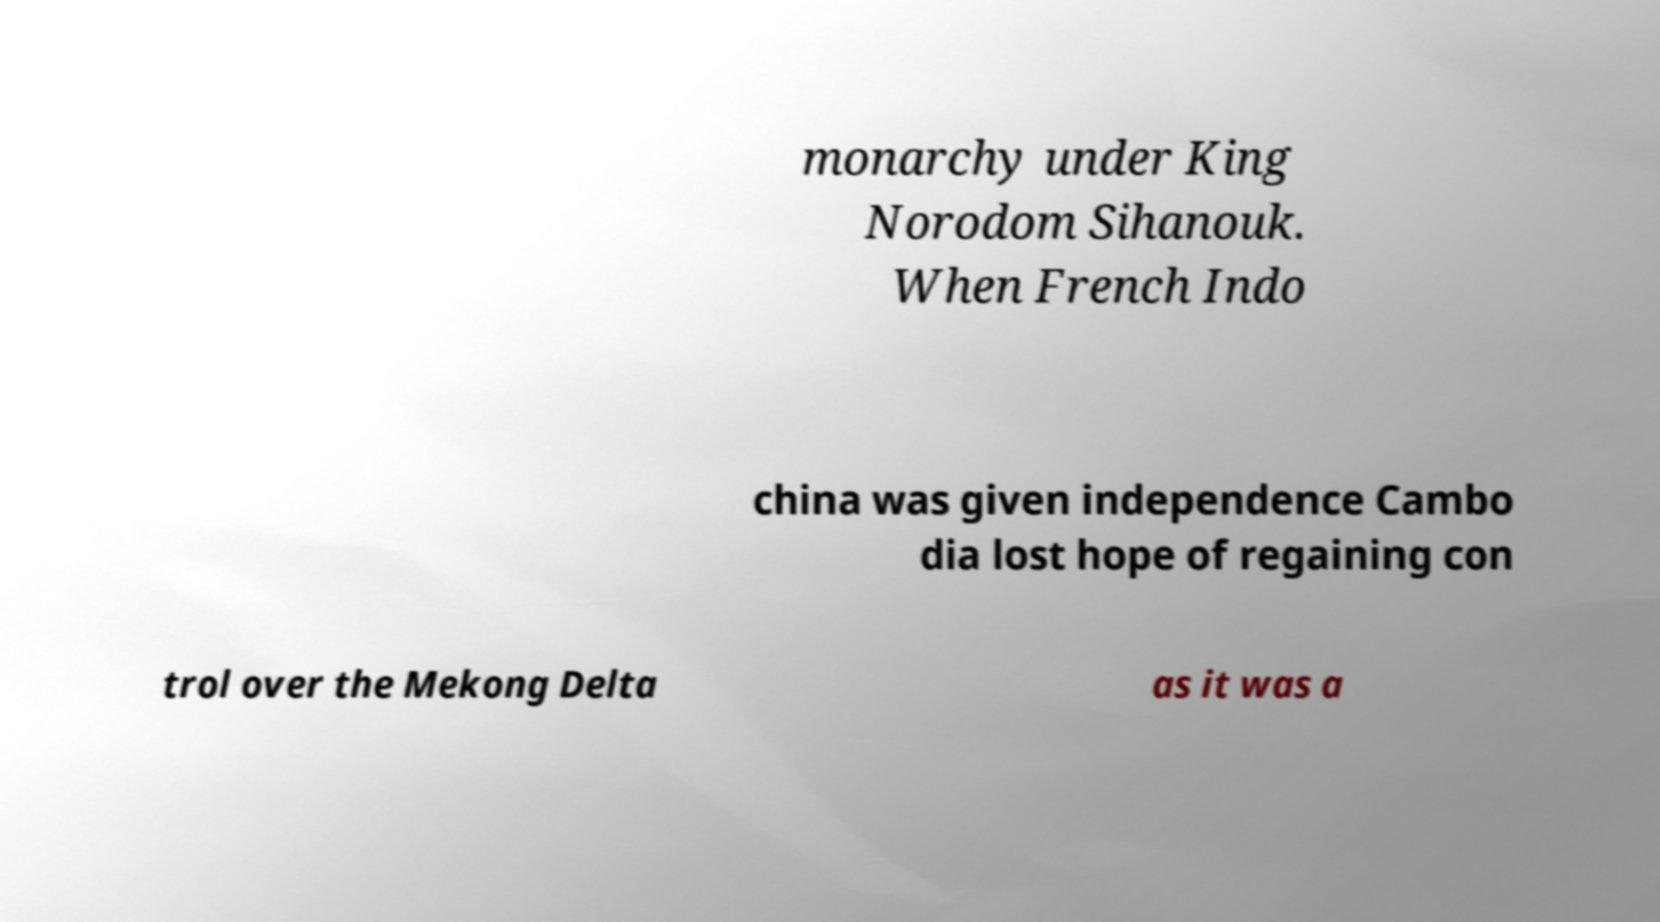Could you extract and type out the text from this image? monarchy under King Norodom Sihanouk. When French Indo china was given independence Cambo dia lost hope of regaining con trol over the Mekong Delta as it was a 